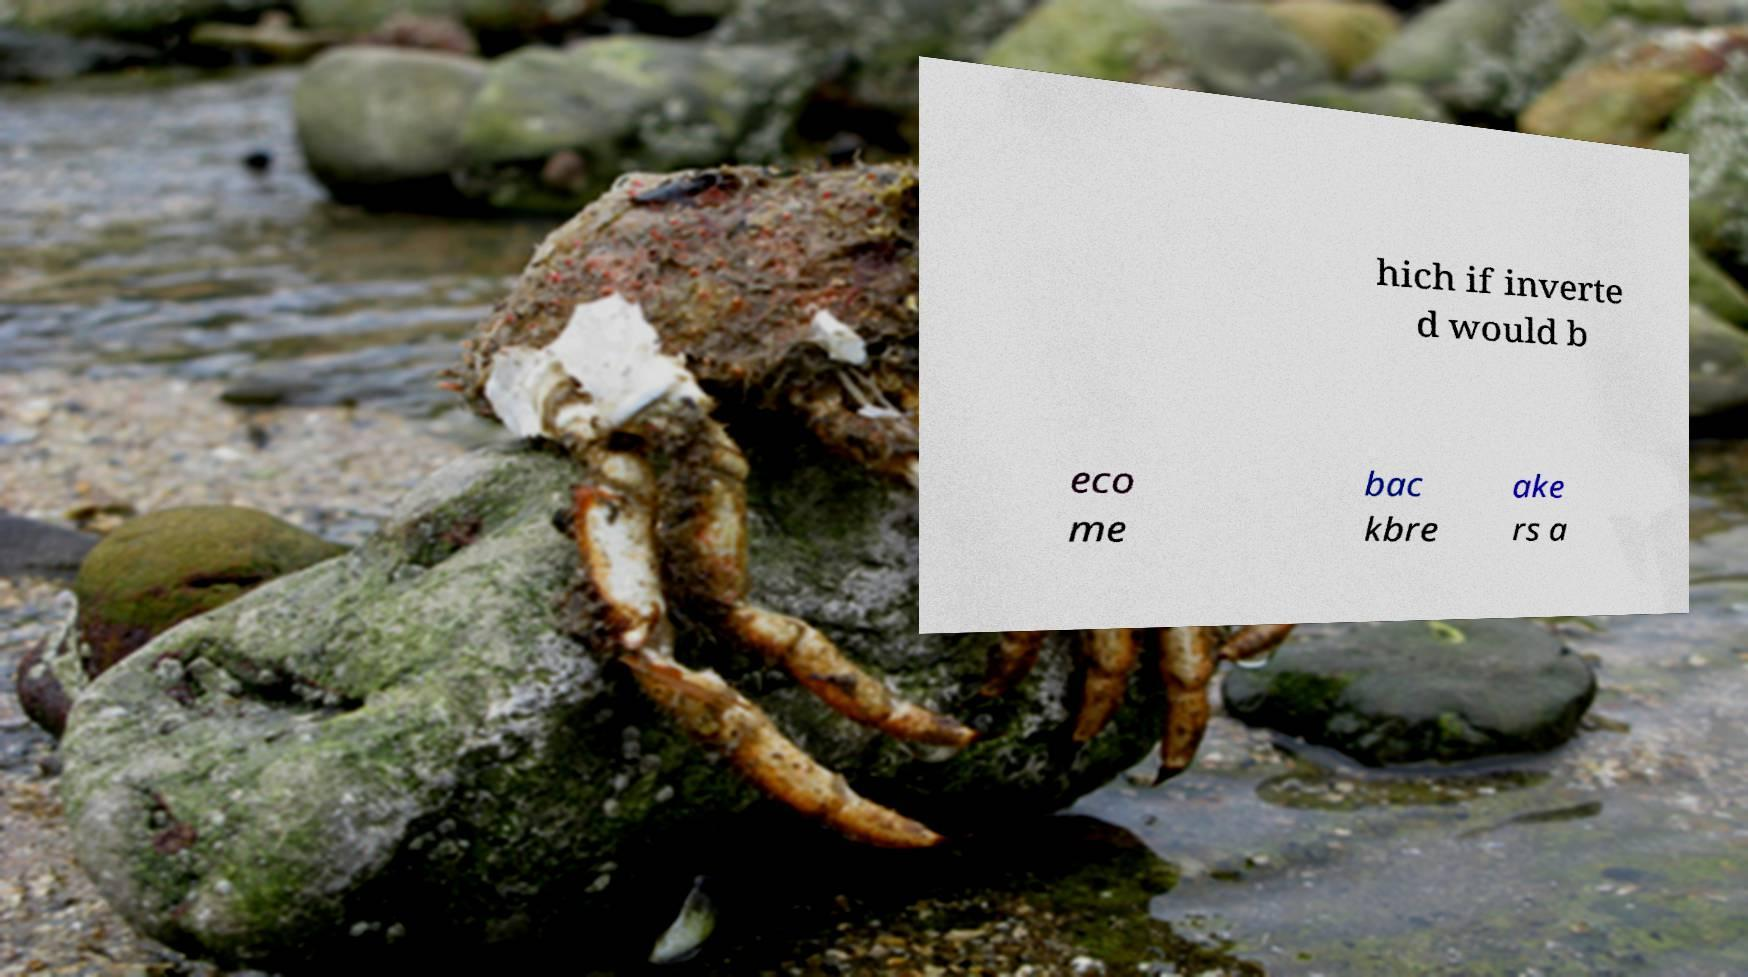Please identify and transcribe the text found in this image. hich if inverte d would b eco me bac kbre ake rs a 